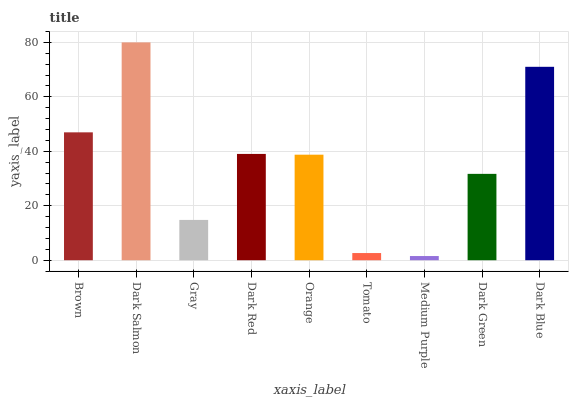Is Gray the minimum?
Answer yes or no. No. Is Gray the maximum?
Answer yes or no. No. Is Dark Salmon greater than Gray?
Answer yes or no. Yes. Is Gray less than Dark Salmon?
Answer yes or no. Yes. Is Gray greater than Dark Salmon?
Answer yes or no. No. Is Dark Salmon less than Gray?
Answer yes or no. No. Is Orange the high median?
Answer yes or no. Yes. Is Orange the low median?
Answer yes or no. Yes. Is Brown the high median?
Answer yes or no. No. Is Dark Red the low median?
Answer yes or no. No. 